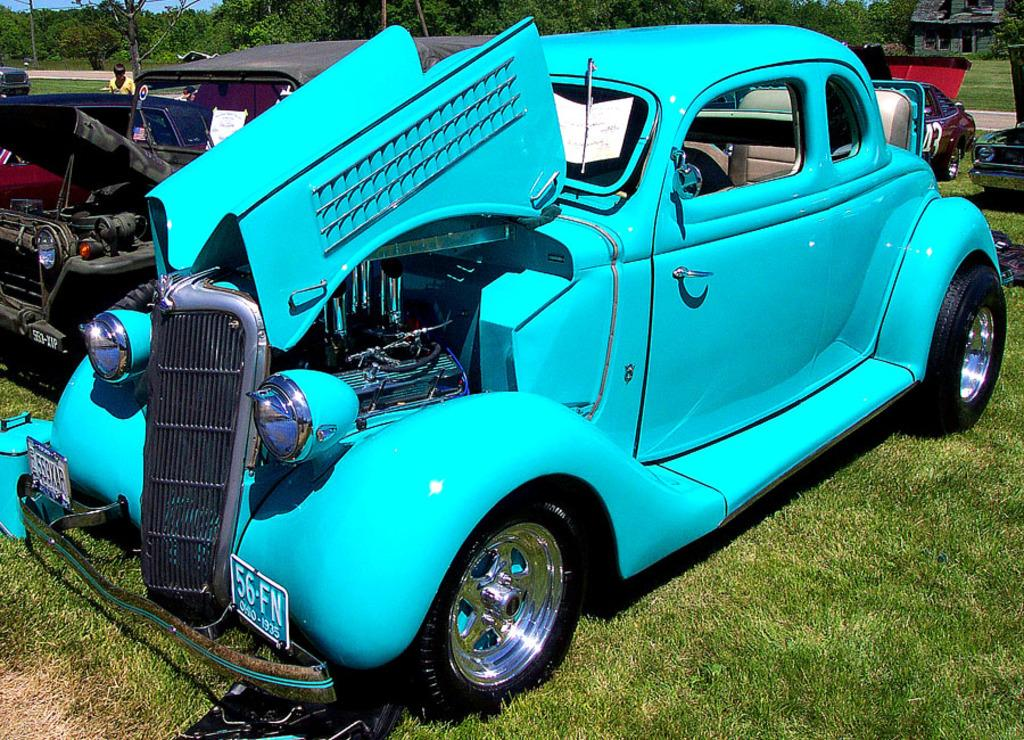What is located on the grass in the image? There are vehicles on the grass in the image. Can you describe the person in the image? There is a person in the image, but their specific appearance or actions are not mentioned in the facts. What can be seen in the background of the image? There are trees and a house in the background of the image. What type of jelly is being used to repair the vehicles in the image? There is no jelly present in the image, and the vehicles do not appear to be in need of repair. Can you tell me how many insects are crawling on the person in the image? There is no mention of insects in the image, so it is impossible to determine their presence or quantity. 